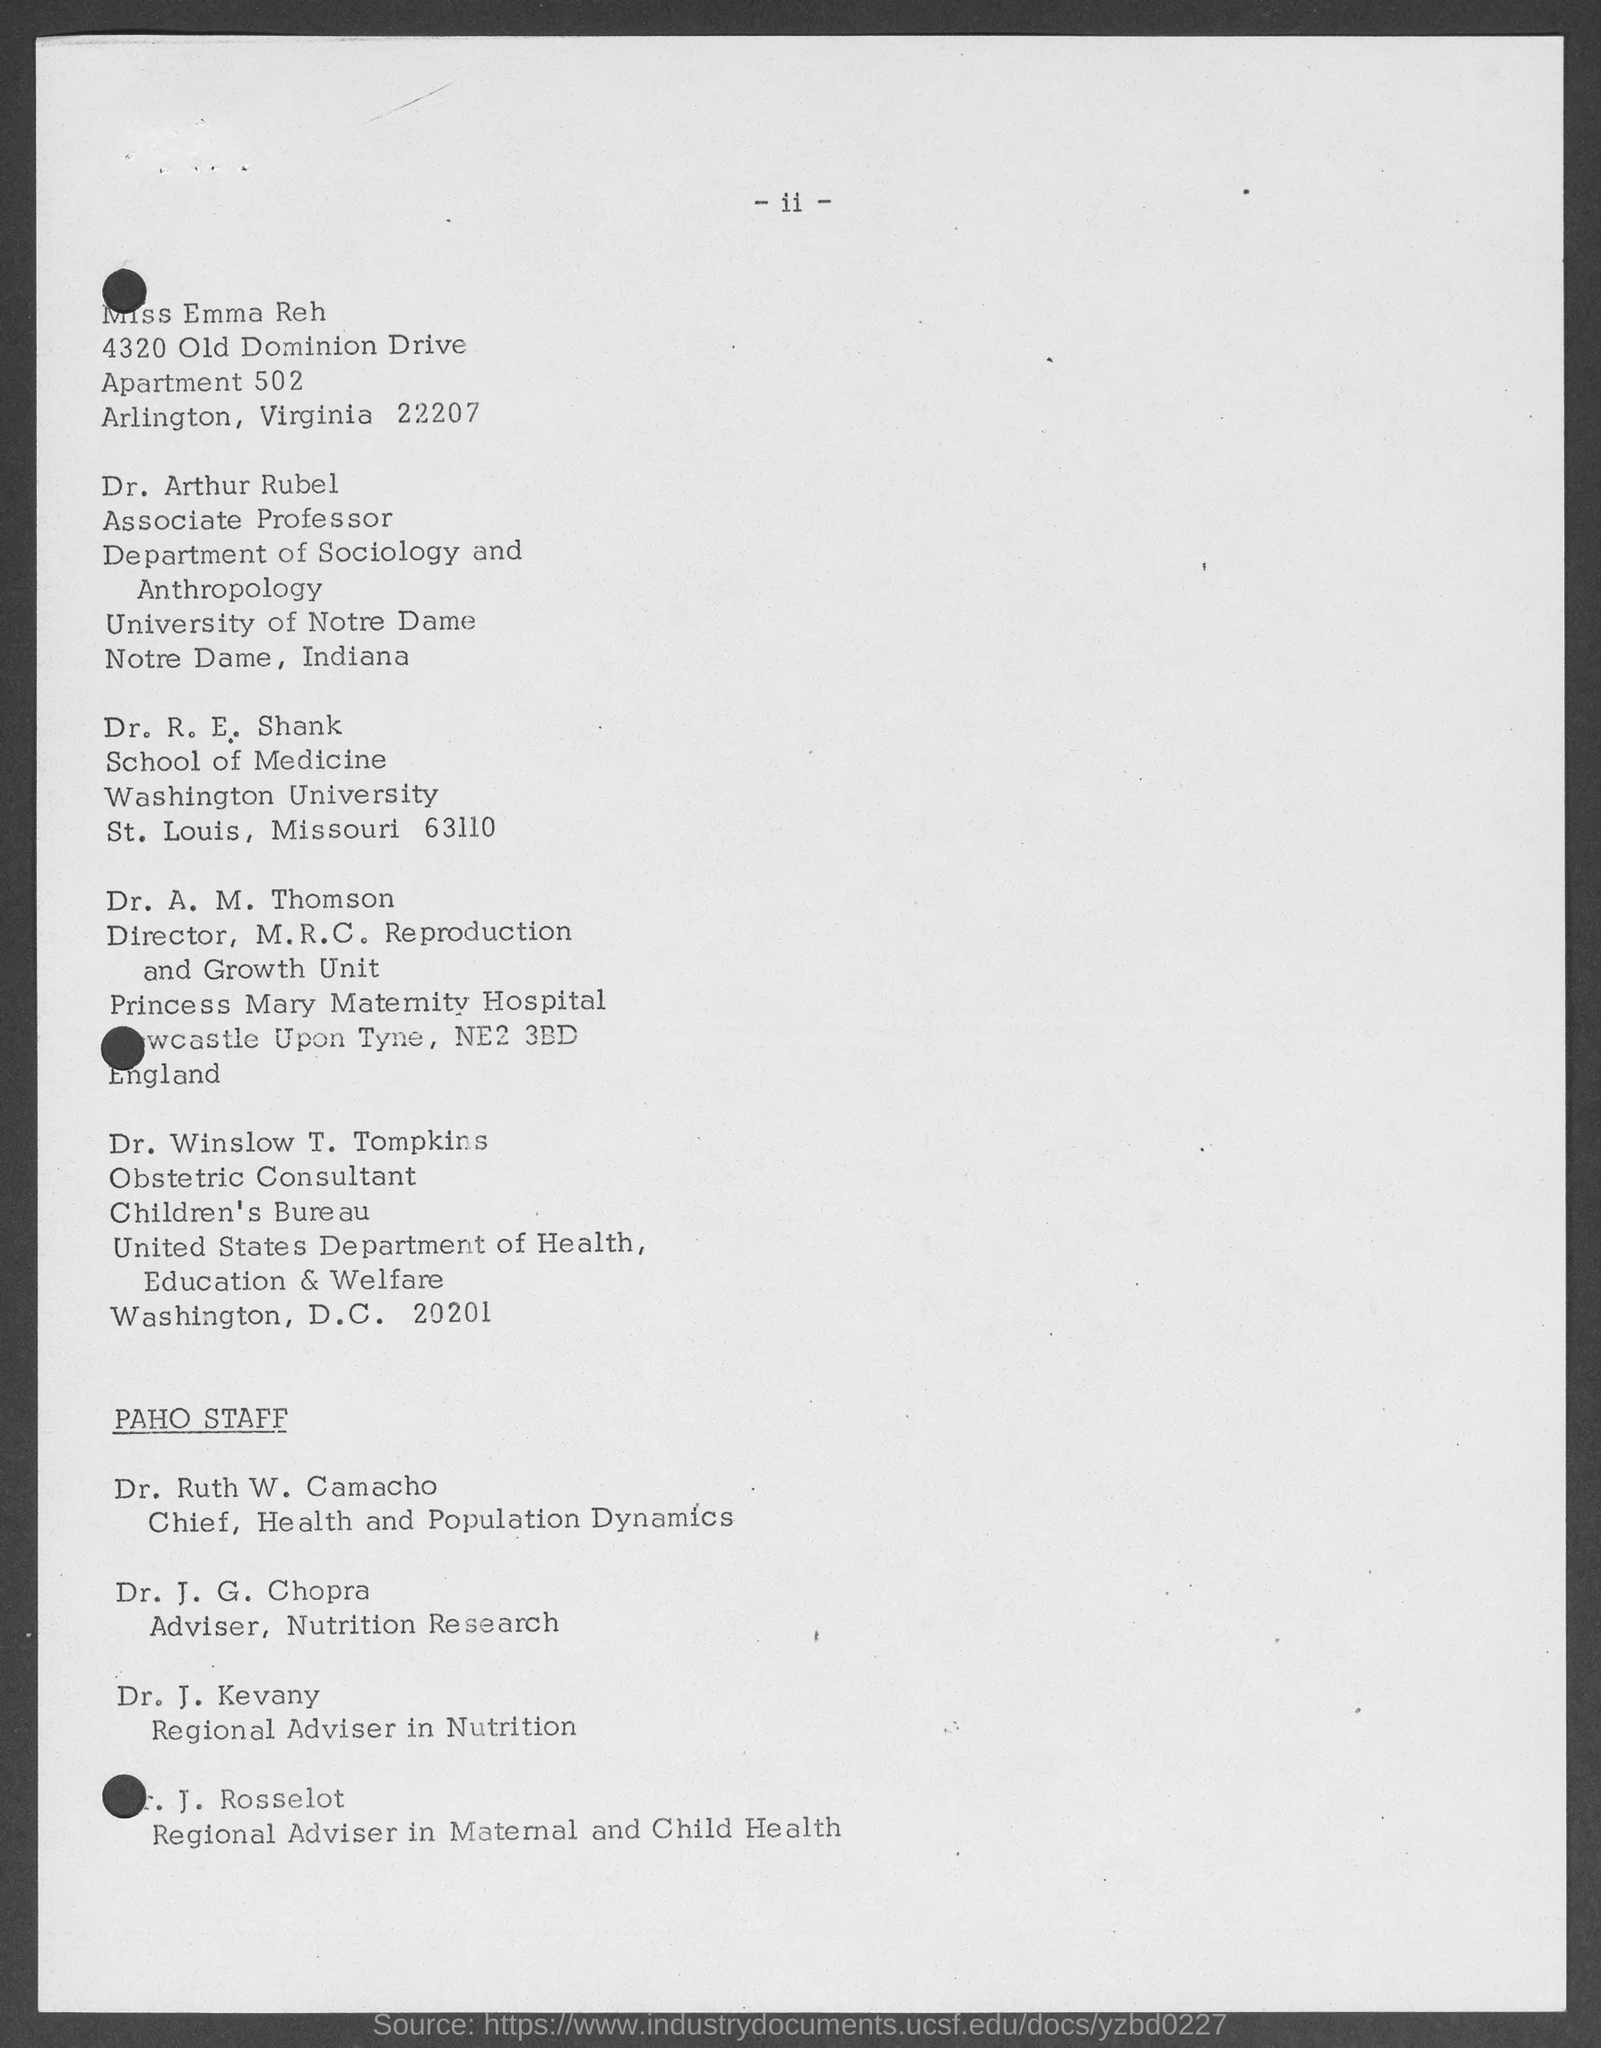Draw attention to some important aspects in this diagram. Dr. R. E. Shank works at Washington University. Dr. Ruth W. Camacho is the chief of the Health and Population Dynamics department. The Regional Adviser in Nutrition is Dr. J. Kevany. Dr. Arthur Rubel works at the University of Notre Dame. Dr. J. G. Chopra holds the designation of Adviser in Nutrition Research. 